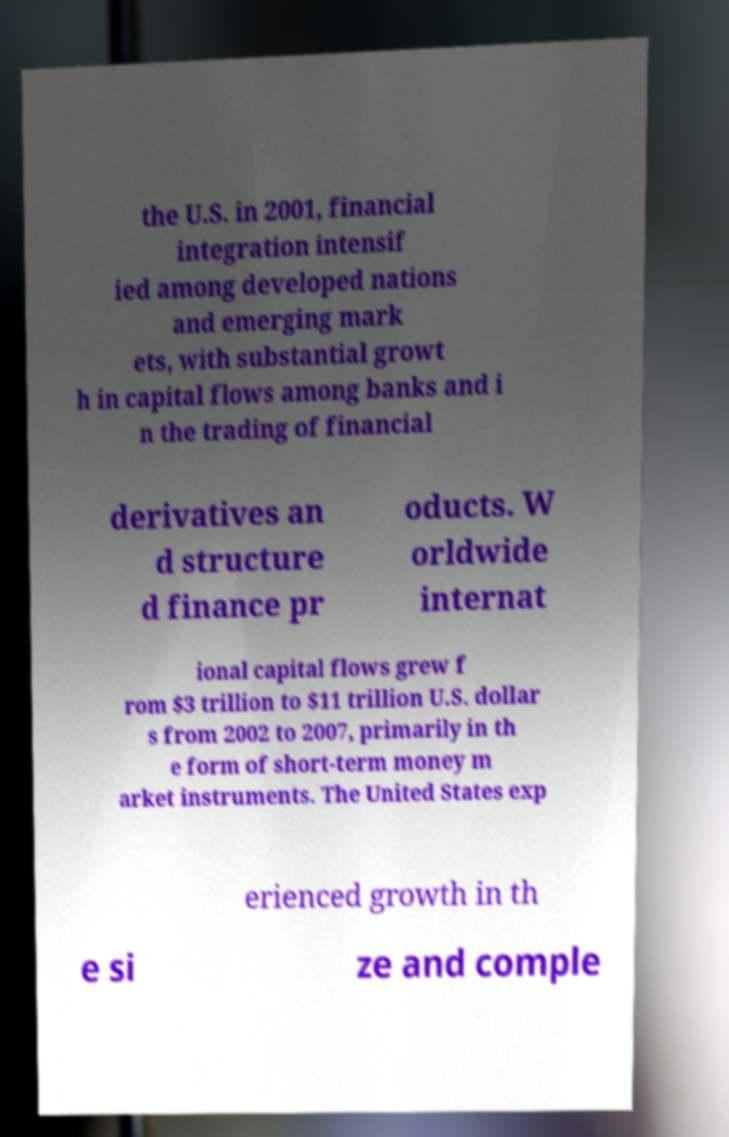Please identify and transcribe the text found in this image. the U.S. in 2001, financial integration intensif ied among developed nations and emerging mark ets, with substantial growt h in capital flows among banks and i n the trading of financial derivatives an d structure d finance pr oducts. W orldwide internat ional capital flows grew f rom $3 trillion to $11 trillion U.S. dollar s from 2002 to 2007, primarily in th e form of short-term money m arket instruments. The United States exp erienced growth in th e si ze and comple 